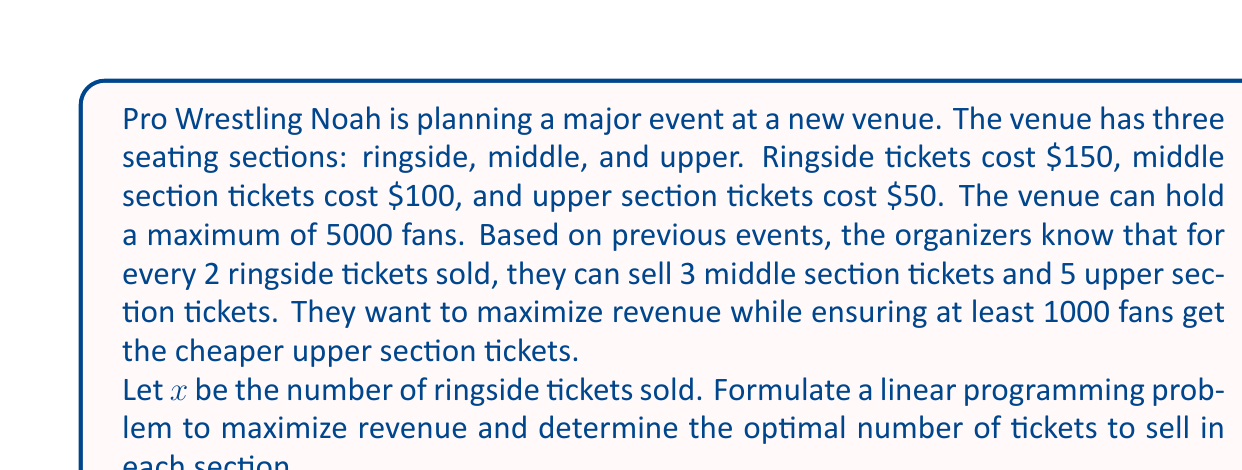Can you answer this question? Let's approach this step-by-step:

1) Define variables:
   $x$ = number of ringside tickets
   $\frac{3}{2}x$ = number of middle section tickets
   $\frac{5}{2}x$ = number of upper section tickets

2) Objective function:
   Maximize revenue = $150x + 100(\frac{3}{2}x) + 50(\frac{5}{2}x)$
   Simplify: Maximize $Z = 150x + 150x + 125x = 425x$

3) Constraints:
   a) Total capacity: $x + \frac{3}{2}x + \frac{5}{2}x \leq 5000$
      Simplify: $5x \leq 5000$ or $x \leq 1000$
   
   b) Minimum upper section tickets: $\frac{5}{2}x \geq 1000$
      Simplify: $x \geq 400$

4) Non-negativity: $x \geq 0$

5) Linear Programming Problem:
   Maximize $Z = 425x$
   Subject to:
   $x \leq 1000$
   $x \geq 400$
   $x \geq 0$

6) The optimal solution will be at the upper bound of $x$, which is 1000.

7) Calculate the number of tickets for each section:
   Ringside: $x = 1000$
   Middle: $\frac{3}{2}x = 1500$
   Upper: $\frac{5}{2}x = 2500$

8) Total revenue: $425 * 1000 = 425,000$
Answer: The optimal solution is to sell 1000 ringside tickets, 1500 middle section tickets, and 2500 upper section tickets, generating a total revenue of $425,000. 